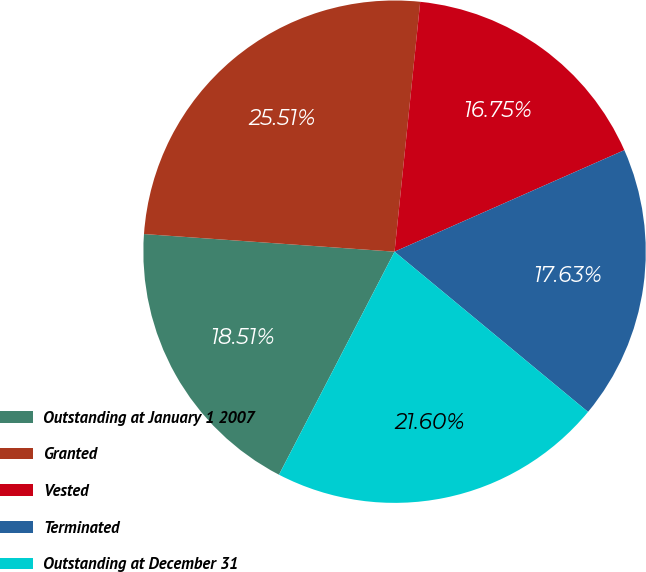Convert chart. <chart><loc_0><loc_0><loc_500><loc_500><pie_chart><fcel>Outstanding at January 1 2007<fcel>Granted<fcel>Vested<fcel>Terminated<fcel>Outstanding at December 31<nl><fcel>18.51%<fcel>25.51%<fcel>16.75%<fcel>17.63%<fcel>21.6%<nl></chart> 